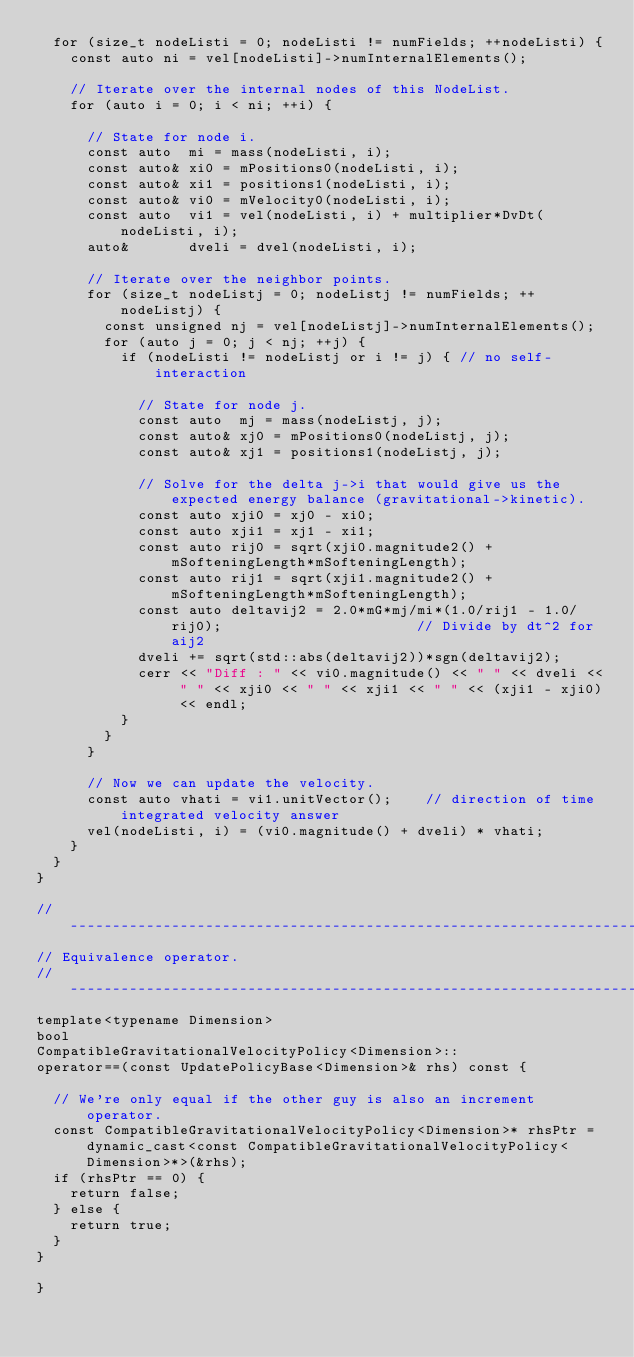<code> <loc_0><loc_0><loc_500><loc_500><_C++_>  for (size_t nodeListi = 0; nodeListi != numFields; ++nodeListi) {
    const auto ni = vel[nodeListi]->numInternalElements();

    // Iterate over the internal nodes of this NodeList.
    for (auto i = 0; i < ni; ++i) {

      // State for node i.
      const auto  mi = mass(nodeListi, i);
      const auto& xi0 = mPositions0(nodeListi, i);
      const auto& xi1 = positions1(nodeListi, i);
      const auto& vi0 = mVelocity0(nodeListi, i);
      const auto  vi1 = vel(nodeListi, i) + multiplier*DvDt(nodeListi, i);
      auto&       dveli = dvel(nodeListi, i);

      // Iterate over the neighbor points.
      for (size_t nodeListj = 0; nodeListj != numFields; ++nodeListj) {
        const unsigned nj = vel[nodeListj]->numInternalElements();
        for (auto j = 0; j < nj; ++j) {
          if (nodeListi != nodeListj or i != j) { // no self-interaction

            // State for node j.
            const auto  mj = mass(nodeListj, j);
            const auto& xj0 = mPositions0(nodeListj, j);
            const auto& xj1 = positions1(nodeListj, j);

            // Solve for the delta j->i that would give us the expected energy balance (gravitational->kinetic).
            const auto xji0 = xj0 - xi0;
            const auto xji1 = xj1 - xi1;
            const auto rij0 = sqrt(xji0.magnitude2() + mSofteningLength*mSofteningLength);
            const auto rij1 = sqrt(xji1.magnitude2() + mSofteningLength*mSofteningLength);
            const auto deltavij2 = 2.0*mG*mj/mi*(1.0/rij1 - 1.0/rij0);                       // Divide by dt^2 for aij2
            dveli += sqrt(std::abs(deltavij2))*sgn(deltavij2);
            cerr << "Diff : " << vi0.magnitude() << " " << dveli << " " << xji0 << " " << xji1 << " " << (xji1 - xji0) << endl;
          }
        }
      }

      // Now we can update the velocity.
      const auto vhati = vi1.unitVector();    // direction of time integrated velocity answer
      vel(nodeListi, i) = (vi0.magnitude() + dveli) * vhati;
    }
  }
}

//------------------------------------------------------------------------------
// Equivalence operator.
//------------------------------------------------------------------------------
template<typename Dimension>
bool
CompatibleGravitationalVelocityPolicy<Dimension>::
operator==(const UpdatePolicyBase<Dimension>& rhs) const {

  // We're only equal if the other guy is also an increment operator.
  const CompatibleGravitationalVelocityPolicy<Dimension>* rhsPtr = dynamic_cast<const CompatibleGravitationalVelocityPolicy<Dimension>*>(&rhs);
  if (rhsPtr == 0) {
    return false;
  } else {
    return true;
  }
}

}

</code> 